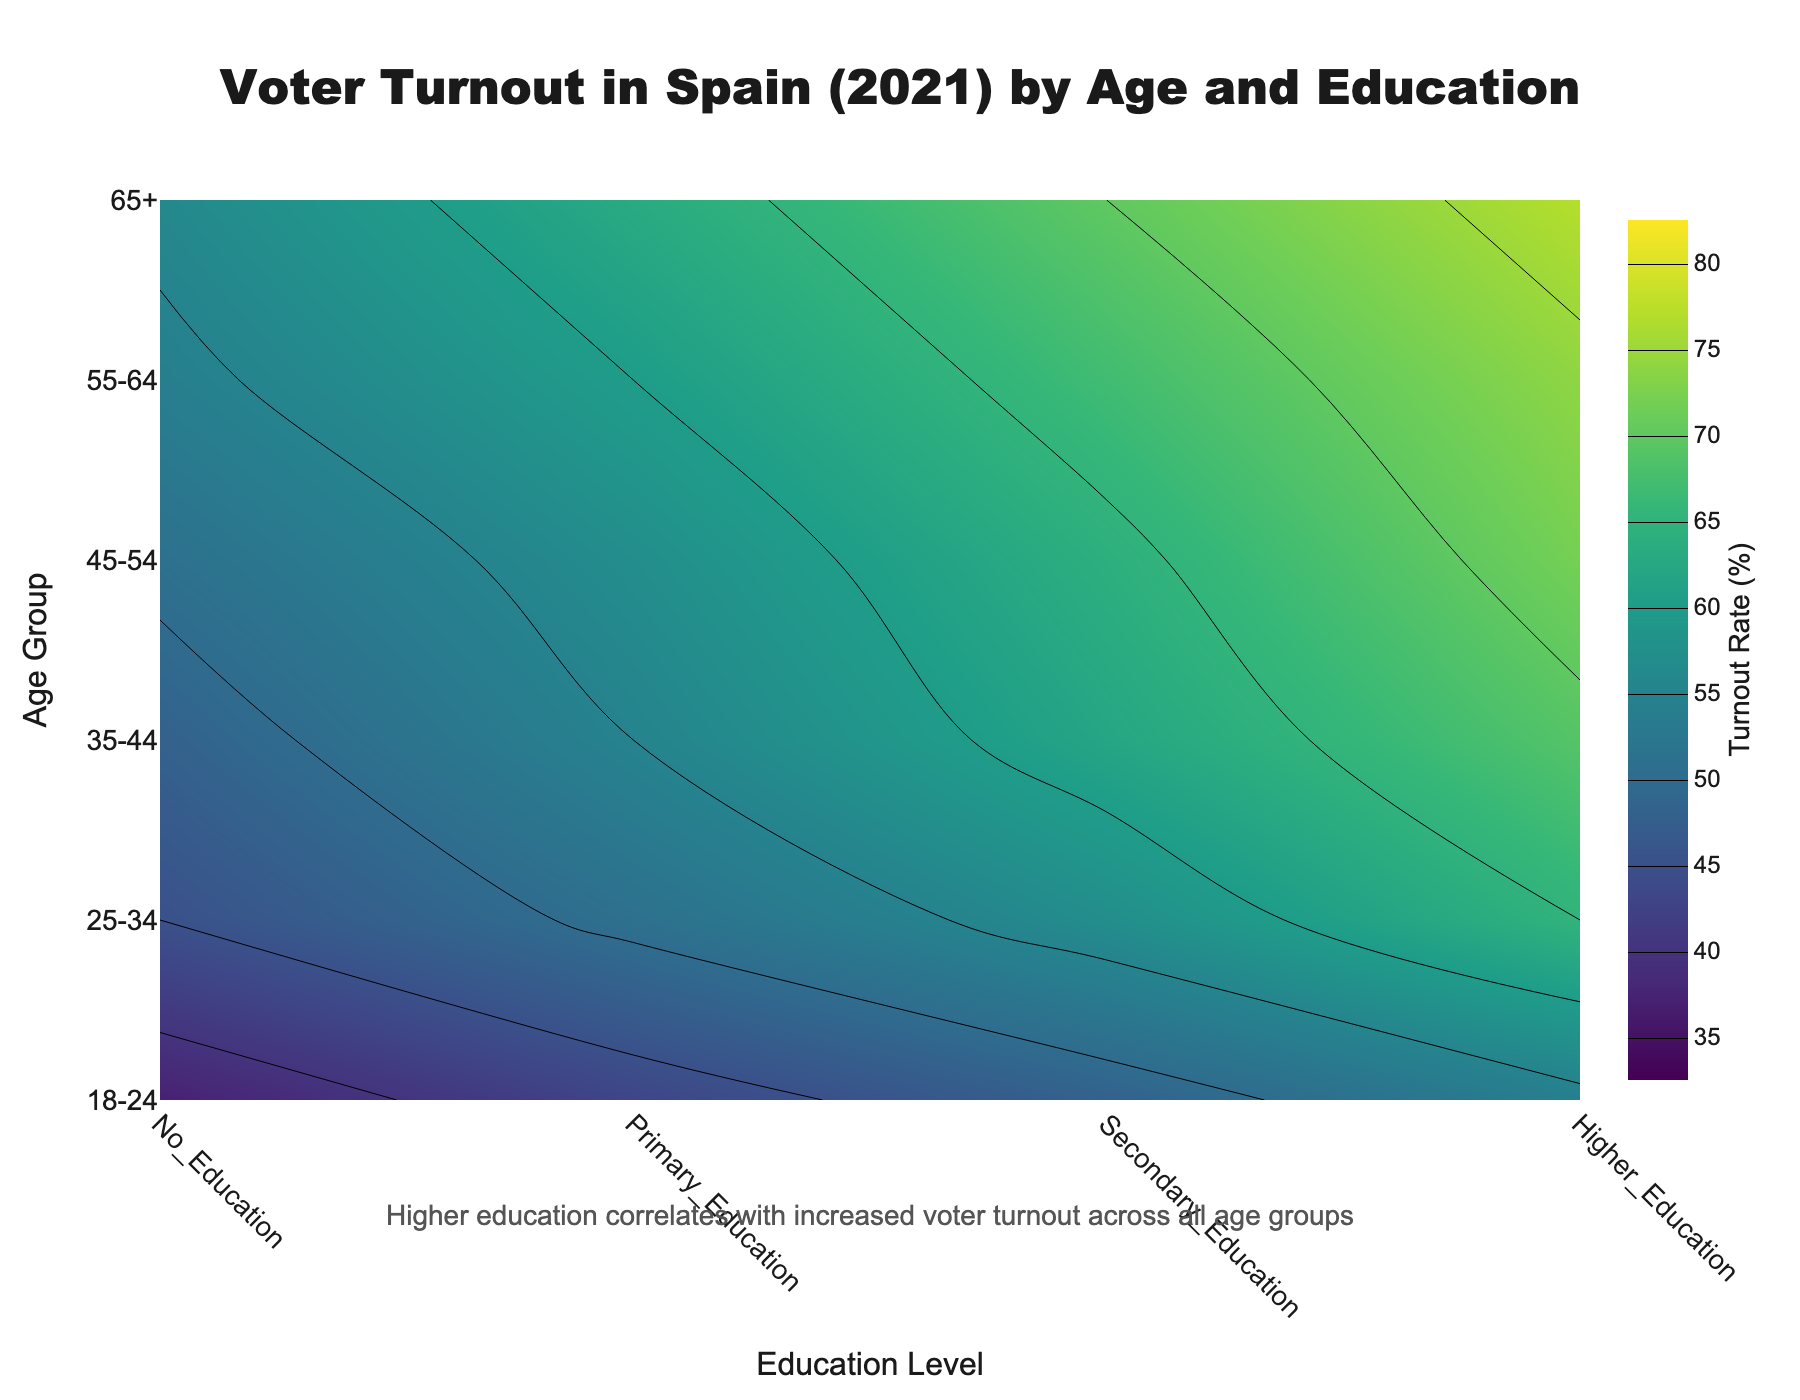What is the title of the contour plot? The title is written at the top of the figure in bold black text.
Answer: Voter Turnout in Spain (2021) by Age and Education What is the education level with the highest voter turnout rate for the age group 65+? The highest turnout rate can be seen at the top right corner of the contour plot under "65+" for the "Higher Education" category.
Answer: Higher Education Which age group has the lowest voter turnout rate and at what education level? Look at the contour plot for the lowest contour lines. The bottom left corner of the plot shows the lowest value under age group "18-24" and education level "No Education".
Answer: 18-24; No Education How does voter turnout change across different education levels for the same age group? By moving horizontally across a row (age group) from left to right, you can observe the variation in contour levels, which usually increase from "No Education" to "Higher Education".
Answer: Increases with higher education Compare the voter turnout rates between the "35-44" and "45-54" age groups for "Secondary Education". Which age group has a higher rate and by how much? Find the contour levels for "35-44" and "45-54" along the "Secondary Education" column. Subtract the rate for "35-44" from "45-54".
Answer: 45-54; 2% For which age group is the difference in voter turnout between "Primary Education" and "Secondary Education" the largest? Calculate voter turnout differences between "Primary Education" and "Secondary Education" for all age groups by moving horizontally across the rows. Identify the maximum difference.
Answer: 18-24 What pattern or correlation is suggested by the annotation at the bottom of the chart? The annotation indicates that higher education correlates with higher voter turnout rates, as observed from the contour levels.
Answer: Higher education correlates with increased voter turnout Which education level shows the most consistent voter turnout across all age groups? Look for the education level where the contour lines are most horizontally stable across all age groups.
Answer: Higher Education What is the color range used in the contour plot to represent voter turnout rates? The color range is displayed in the color bar on the right side of the plot, with darker shades indicating lower turnout and lighter shades indicating higher turnout.
Answer: Viridis color scale, from dark to light 